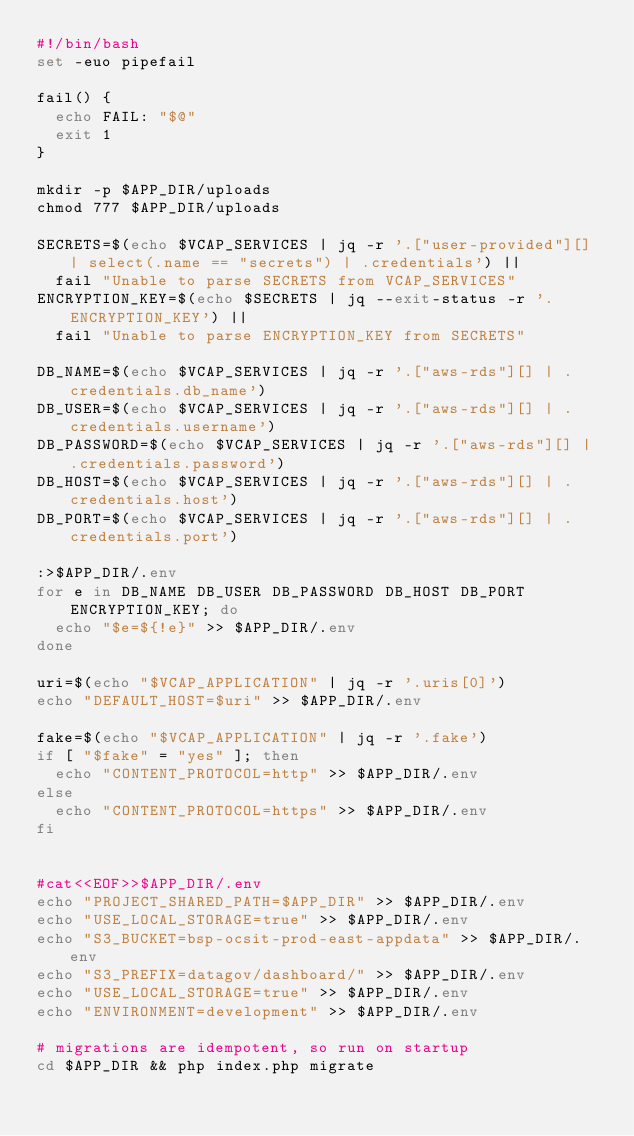<code> <loc_0><loc_0><loc_500><loc_500><_Bash_>#!/bin/bash 
set -euo pipefail

fail() {
  echo FAIL: "$@"
  exit 1
}

mkdir -p $APP_DIR/uploads
chmod 777 $APP_DIR/uploads

SECRETS=$(echo $VCAP_SERVICES | jq -r '.["user-provided"][] | select(.name == "secrets") | .credentials') ||
  fail "Unable to parse SECRETS from VCAP_SERVICES"
ENCRYPTION_KEY=$(echo $SECRETS | jq --exit-status -r '.ENCRYPTION_KEY') ||
  fail "Unable to parse ENCRYPTION_KEY from SECRETS"

DB_NAME=$(echo $VCAP_SERVICES | jq -r '.["aws-rds"][] | .credentials.db_name')
DB_USER=$(echo $VCAP_SERVICES | jq -r '.["aws-rds"][] | .credentials.username')
DB_PASSWORD=$(echo $VCAP_SERVICES | jq -r '.["aws-rds"][] | .credentials.password')
DB_HOST=$(echo $VCAP_SERVICES | jq -r '.["aws-rds"][] | .credentials.host')
DB_PORT=$(echo $VCAP_SERVICES | jq -r '.["aws-rds"][] | .credentials.port')

:>$APP_DIR/.env
for e in DB_NAME DB_USER DB_PASSWORD DB_HOST DB_PORT ENCRYPTION_KEY; do 
  echo "$e=${!e}" >> $APP_DIR/.env
done 

uri=$(echo "$VCAP_APPLICATION" | jq -r '.uris[0]')
echo "DEFAULT_HOST=$uri" >> $APP_DIR/.env

fake=$(echo "$VCAP_APPLICATION" | jq -r '.fake')
if [ "$fake" = "yes" ]; then
  echo "CONTENT_PROTOCOL=http" >> $APP_DIR/.env
else
  echo "CONTENT_PROTOCOL=https" >> $APP_DIR/.env
fi


#cat<<EOF>>$APP_DIR/.env
echo "PROJECT_SHARED_PATH=$APP_DIR" >> $APP_DIR/.env
echo "USE_LOCAL_STORAGE=true" >> $APP_DIR/.env
echo "S3_BUCKET=bsp-ocsit-prod-east-appdata" >> $APP_DIR/.env
echo "S3_PREFIX=datagov/dashboard/" >> $APP_DIR/.env
echo "USE_LOCAL_STORAGE=true" >> $APP_DIR/.env
echo "ENVIRONMENT=development" >> $APP_DIR/.env

# migrations are idempotent, so run on startup
cd $APP_DIR && php index.php migrate
</code> 